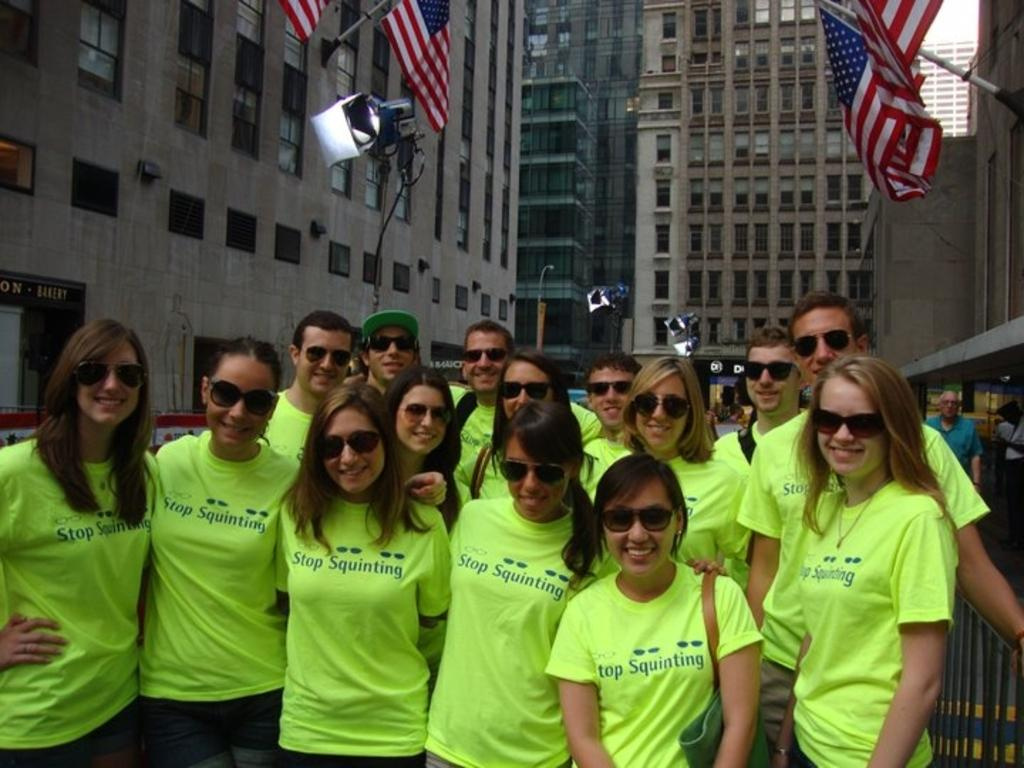How many people are in the image? There is a group of people in the image, but the exact number is not specified. What is the location of the group of people in the image? The group of people is in front of a building. What decorations are on the building? There are flags on the building. What objects are visible in the middle of the image? There are cameras visible in the middle of the image. What type of vacation is the group of people enjoying in the image? There is no indication of a vacation in the image; it simply shows a group of people in front of a building with flags and cameras. 